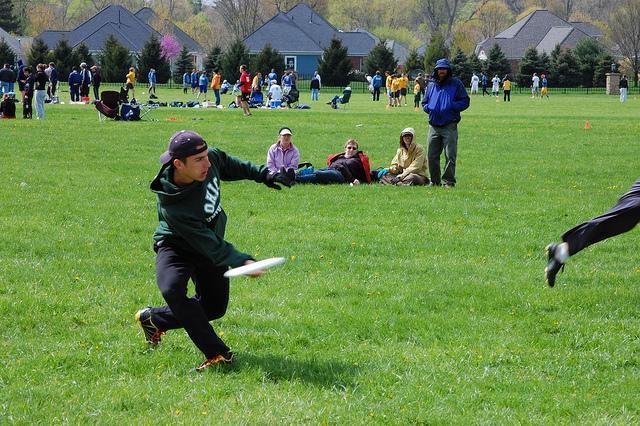How many people are there?
Give a very brief answer. 3. 